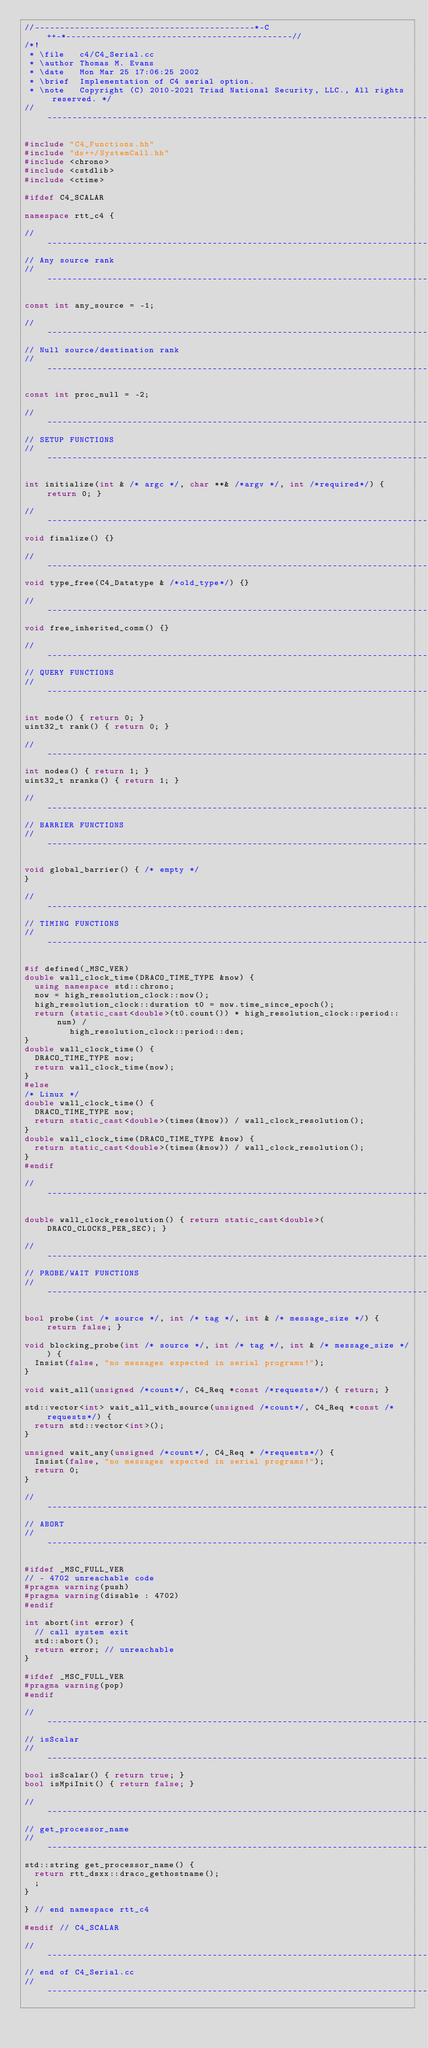<code> <loc_0><loc_0><loc_500><loc_500><_C++_>//--------------------------------------------*-C++-*---------------------------------------------//
/*!
 * \file   c4/C4_Serial.cc
 * \author Thomas M. Evans
 * \date   Mon Mar 25 17:06:25 2002
 * \brief  Implementation of C4 serial option.
 * \note   Copyright (C) 2010-2021 Triad National Security, LLC., All rights reserved. */
//------------------------------------------------------------------------------------------------//

#include "C4_Functions.hh"
#include "ds++/SystemCall.hh"
#include <chrono>
#include <cstdlib>
#include <ctime>

#ifdef C4_SCALAR

namespace rtt_c4 {

//------------------------------------------------------------------------------------------------//
// Any source rank
//------------------------------------------------------------------------------------------------//

const int any_source = -1;

//------------------------------------------------------------------------------------------------//
// Null source/destination rank
//------------------------------------------------------------------------------------------------//

const int proc_null = -2;

//------------------------------------------------------------------------------------------------//
// SETUP FUNCTIONS
//------------------------------------------------------------------------------------------------//

int initialize(int & /* argc */, char **& /*argv */, int /*required*/) { return 0; }

//------------------------------------------------------------------------------------------------//
void finalize() {}

//------------------------------------------------------------------------------------------------//
void type_free(C4_Datatype & /*old_type*/) {}

//------------------------------------------------------------------------------------------------//
void free_inherited_comm() {}

//------------------------------------------------------------------------------------------------//
// QUERY FUNCTIONS
//------------------------------------------------------------------------------------------------//

int node() { return 0; }
uint32_t rank() { return 0; }

//------------------------------------------------------------------------------------------------//
int nodes() { return 1; }
uint32_t nranks() { return 1; }

//------------------------------------------------------------------------------------------------//
// BARRIER FUNCTIONS
//------------------------------------------------------------------------------------------------//

void global_barrier() { /* empty */
}

//------------------------------------------------------------------------------------------------//
// TIMING FUNCTIONS
//------------------------------------------------------------------------------------------------//

#if defined(_MSC_VER)
double wall_clock_time(DRACO_TIME_TYPE &now) {
  using namespace std::chrono;
  now = high_resolution_clock::now();
  high_resolution_clock::duration t0 = now.time_since_epoch();
  return (static_cast<double>(t0.count()) * high_resolution_clock::period::num) /
         high_resolution_clock::period::den;
}
double wall_clock_time() {
  DRACO_TIME_TYPE now;
  return wall_clock_time(now);
}
#else
/* Linux */
double wall_clock_time() {
  DRACO_TIME_TYPE now;
  return static_cast<double>(times(&now)) / wall_clock_resolution();
}
double wall_clock_time(DRACO_TIME_TYPE &now) {
  return static_cast<double>(times(&now)) / wall_clock_resolution();
}
#endif

//------------------------------------------------------------------------------------------------//

double wall_clock_resolution() { return static_cast<double>(DRACO_CLOCKS_PER_SEC); }

//------------------------------------------------------------------------------------------------//
// PROBE/WAIT FUNCTIONS
//------------------------------------------------------------------------------------------------//

bool probe(int /* source */, int /* tag */, int & /* message_size */) { return false; }

void blocking_probe(int /* source */, int /* tag */, int & /* message_size */) {
  Insist(false, "no messages expected in serial programs!");
}

void wait_all(unsigned /*count*/, C4_Req *const /*requests*/) { return; }

std::vector<int> wait_all_with_source(unsigned /*count*/, C4_Req *const /*requests*/) {
  return std::vector<int>();
}

unsigned wait_any(unsigned /*count*/, C4_Req * /*requests*/) {
  Insist(false, "no messages expected in serial programs!");
  return 0;
}

//------------------------------------------------------------------------------------------------//
// ABORT
//------------------------------------------------------------------------------------------------//

#ifdef _MSC_FULL_VER
// - 4702 unreachable code
#pragma warning(push)
#pragma warning(disable : 4702)
#endif

int abort(int error) {
  // call system exit
  std::abort();
  return error; // unreachable
}

#ifdef _MSC_FULL_VER
#pragma warning(pop)
#endif

//------------------------------------------------------------------------------------------------//
// isScalar
//------------------------------------------------------------------------------------------------//
bool isScalar() { return true; }
bool isMpiInit() { return false; }

//------------------------------------------------------------------------------------------------//
// get_processor_name
//------------------------------------------------------------------------------------------------//
std::string get_processor_name() {
  return rtt_dsxx::draco_gethostname();
  ;
}

} // end namespace rtt_c4

#endif // C4_SCALAR

//------------------------------------------------------------------------------------------------//
// end of C4_Serial.cc
//------------------------------------------------------------------------------------------------//
</code> 